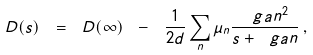Convert formula to latex. <formula><loc_0><loc_0><loc_500><loc_500>D ( s ) \ = \ D ( \infty ) \ - \ \frac { 1 } { 2 d } \sum _ { n } \mu _ { n } \frac { \ g a n ^ { 2 } } { s + \ g a n } \, ,</formula> 